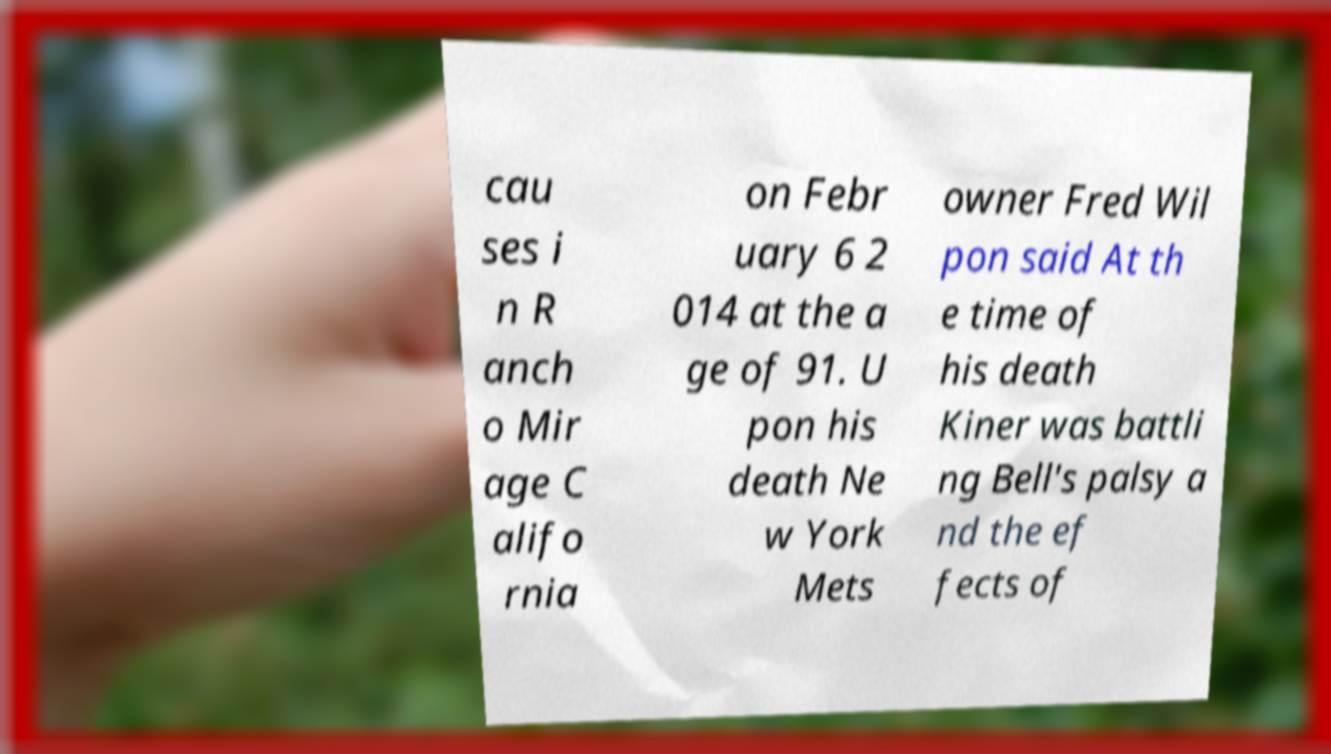Can you read and provide the text displayed in the image?This photo seems to have some interesting text. Can you extract and type it out for me? cau ses i n R anch o Mir age C alifo rnia on Febr uary 6 2 014 at the a ge of 91. U pon his death Ne w York Mets owner Fred Wil pon said At th e time of his death Kiner was battli ng Bell's palsy a nd the ef fects of 